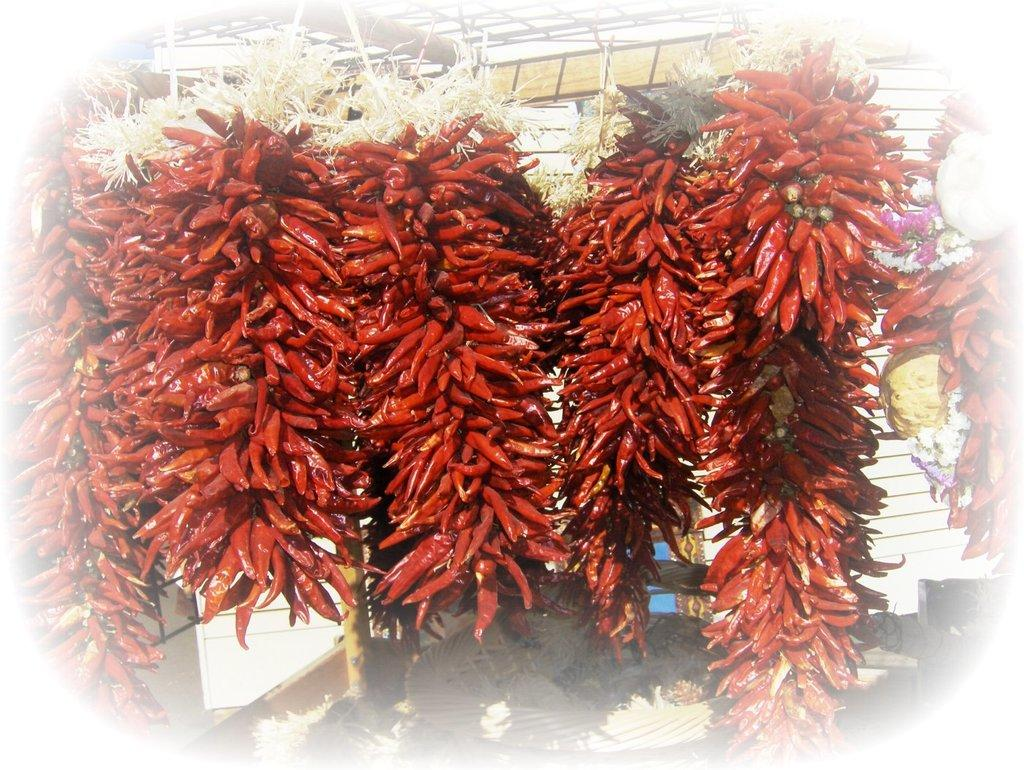What type of food item is present in the image? There are chillies in the image. What color are the chillies? The chillies are in red color. How much money is being exchanged between the birds in the image? There are no birds or money present in the image; it only features red chillies. 